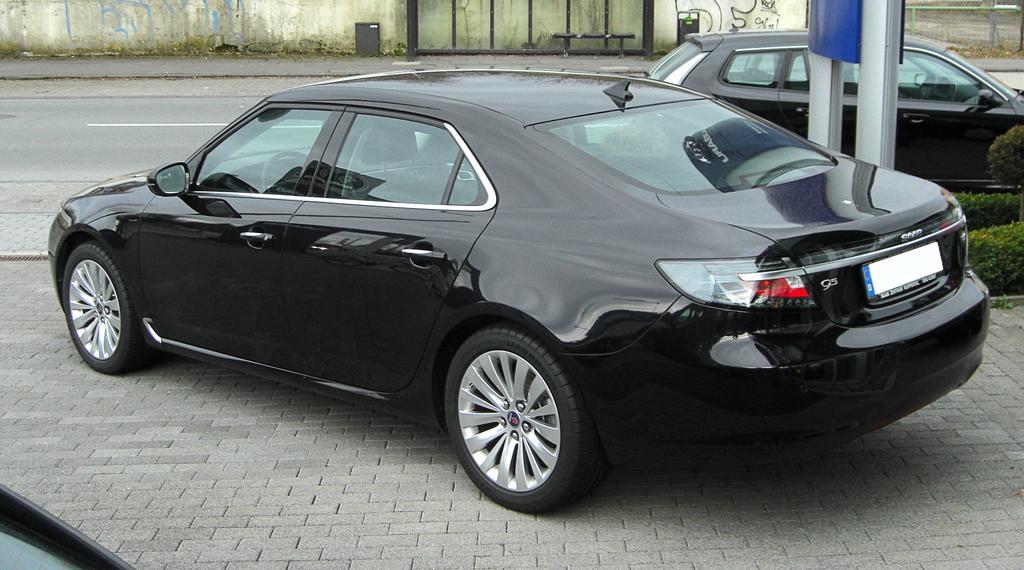How many cars are present in the image? There are two cars in the image. What other objects can be seen in the image besides the cars? There are poles, plants, a bench, a dustbin, and a wall in the image. Can you describe the plants in the image? The plants are visible in the image, but their specific type is not mentioned. What is the purpose of the dustbin in the image? The dustbin is likely used for disposing of waste in the area. How much profit does the wing in the image generate? There is no wing present in the image, so it is not possible to determine any profit generated. 